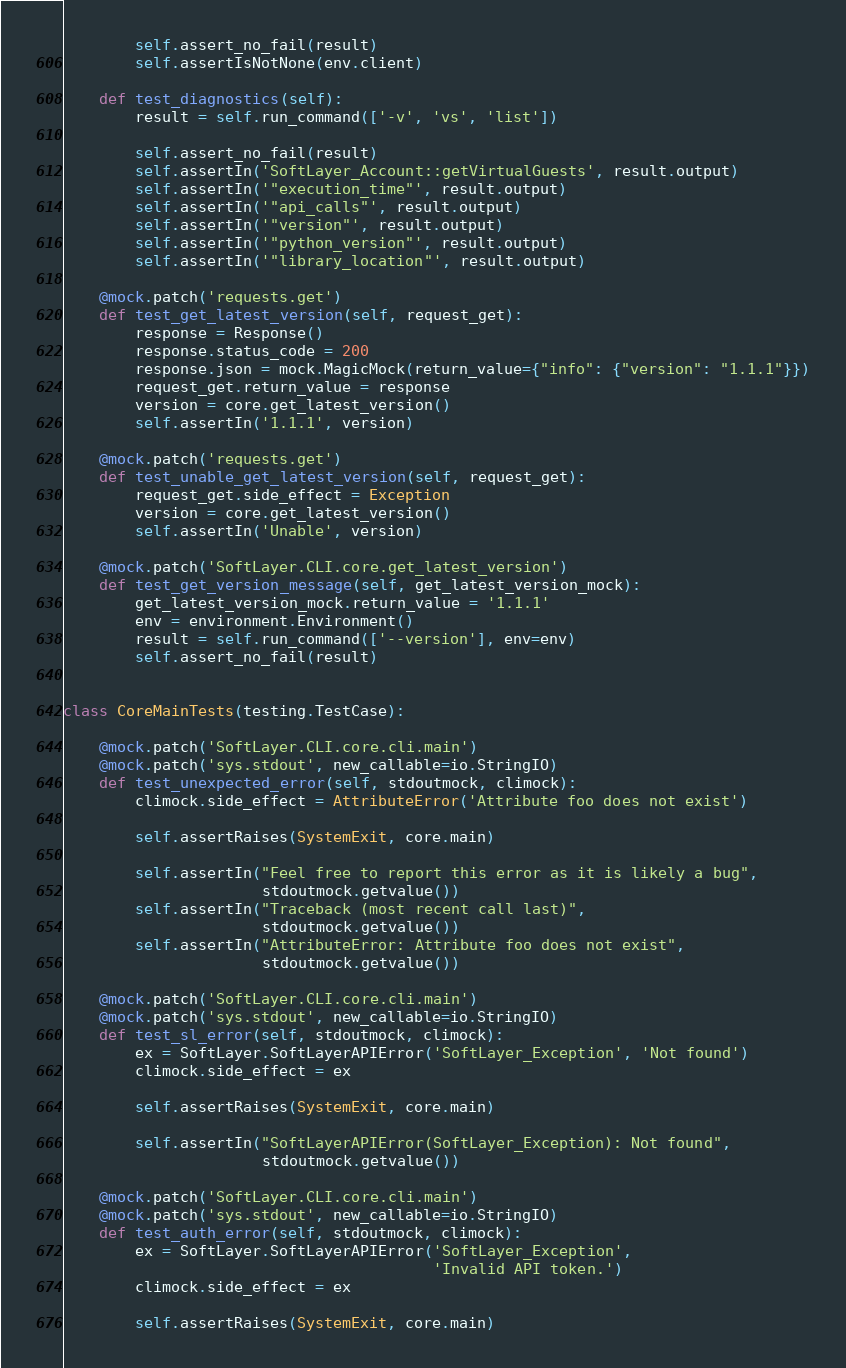<code> <loc_0><loc_0><loc_500><loc_500><_Python_>
        self.assert_no_fail(result)
        self.assertIsNotNone(env.client)

    def test_diagnostics(self):
        result = self.run_command(['-v', 'vs', 'list'])

        self.assert_no_fail(result)
        self.assertIn('SoftLayer_Account::getVirtualGuests', result.output)
        self.assertIn('"execution_time"', result.output)
        self.assertIn('"api_calls"', result.output)
        self.assertIn('"version"', result.output)
        self.assertIn('"python_version"', result.output)
        self.assertIn('"library_location"', result.output)

    @mock.patch('requests.get')
    def test_get_latest_version(self, request_get):
        response = Response()
        response.status_code = 200
        response.json = mock.MagicMock(return_value={"info": {"version": "1.1.1"}})
        request_get.return_value = response
        version = core.get_latest_version()
        self.assertIn('1.1.1', version)

    @mock.patch('requests.get')
    def test_unable_get_latest_version(self, request_get):
        request_get.side_effect = Exception
        version = core.get_latest_version()
        self.assertIn('Unable', version)

    @mock.patch('SoftLayer.CLI.core.get_latest_version')
    def test_get_version_message(self, get_latest_version_mock):
        get_latest_version_mock.return_value = '1.1.1'
        env = environment.Environment()
        result = self.run_command(['--version'], env=env)
        self.assert_no_fail(result)


class CoreMainTests(testing.TestCase):

    @mock.patch('SoftLayer.CLI.core.cli.main')
    @mock.patch('sys.stdout', new_callable=io.StringIO)
    def test_unexpected_error(self, stdoutmock, climock):
        climock.side_effect = AttributeError('Attribute foo does not exist')

        self.assertRaises(SystemExit, core.main)

        self.assertIn("Feel free to report this error as it is likely a bug",
                      stdoutmock.getvalue())
        self.assertIn("Traceback (most recent call last)",
                      stdoutmock.getvalue())
        self.assertIn("AttributeError: Attribute foo does not exist",
                      stdoutmock.getvalue())

    @mock.patch('SoftLayer.CLI.core.cli.main')
    @mock.patch('sys.stdout', new_callable=io.StringIO)
    def test_sl_error(self, stdoutmock, climock):
        ex = SoftLayer.SoftLayerAPIError('SoftLayer_Exception', 'Not found')
        climock.side_effect = ex

        self.assertRaises(SystemExit, core.main)

        self.assertIn("SoftLayerAPIError(SoftLayer_Exception): Not found",
                      stdoutmock.getvalue())

    @mock.patch('SoftLayer.CLI.core.cli.main')
    @mock.patch('sys.stdout', new_callable=io.StringIO)
    def test_auth_error(self, stdoutmock, climock):
        ex = SoftLayer.SoftLayerAPIError('SoftLayer_Exception',
                                         'Invalid API token.')
        climock.side_effect = ex

        self.assertRaises(SystemExit, core.main)
</code> 